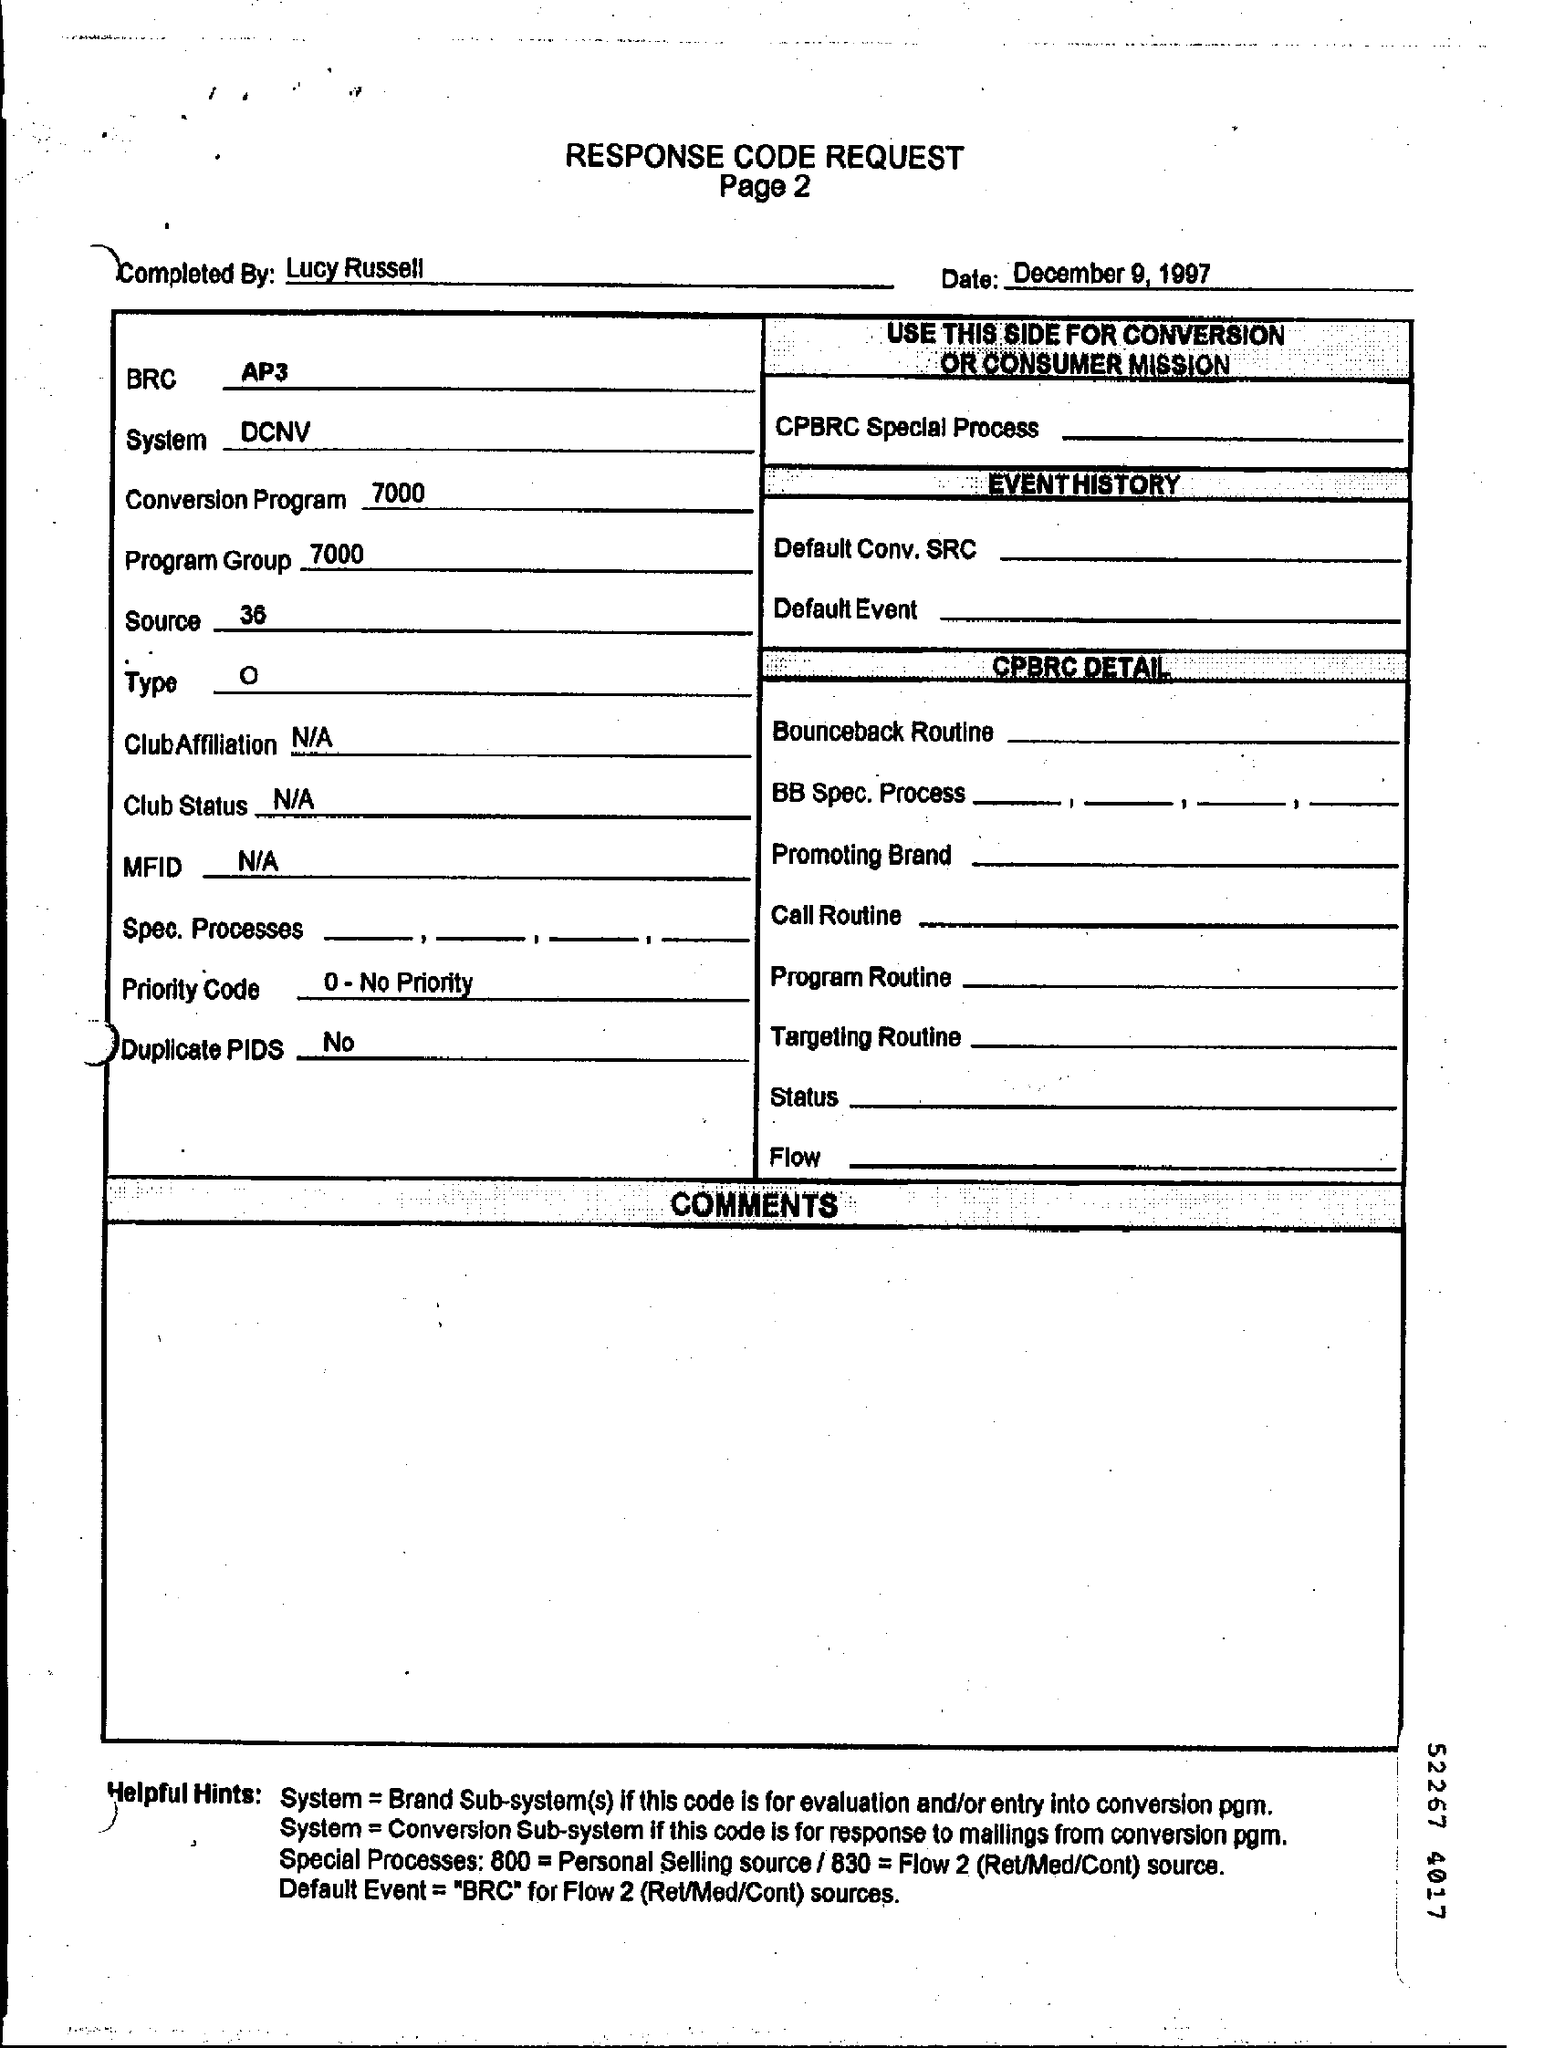Point out several critical features in this image. What is source? As of version 36, it is a software that allows users to connect their computer to multiple devices. MFID, or Mutual Fund Investment Declaration, is not available. The number of pages is two. The date of the document is December 9, 1997. BRC is a term used in the AP3 field, referring to a specific concept or idea related to the AP3 industry. 